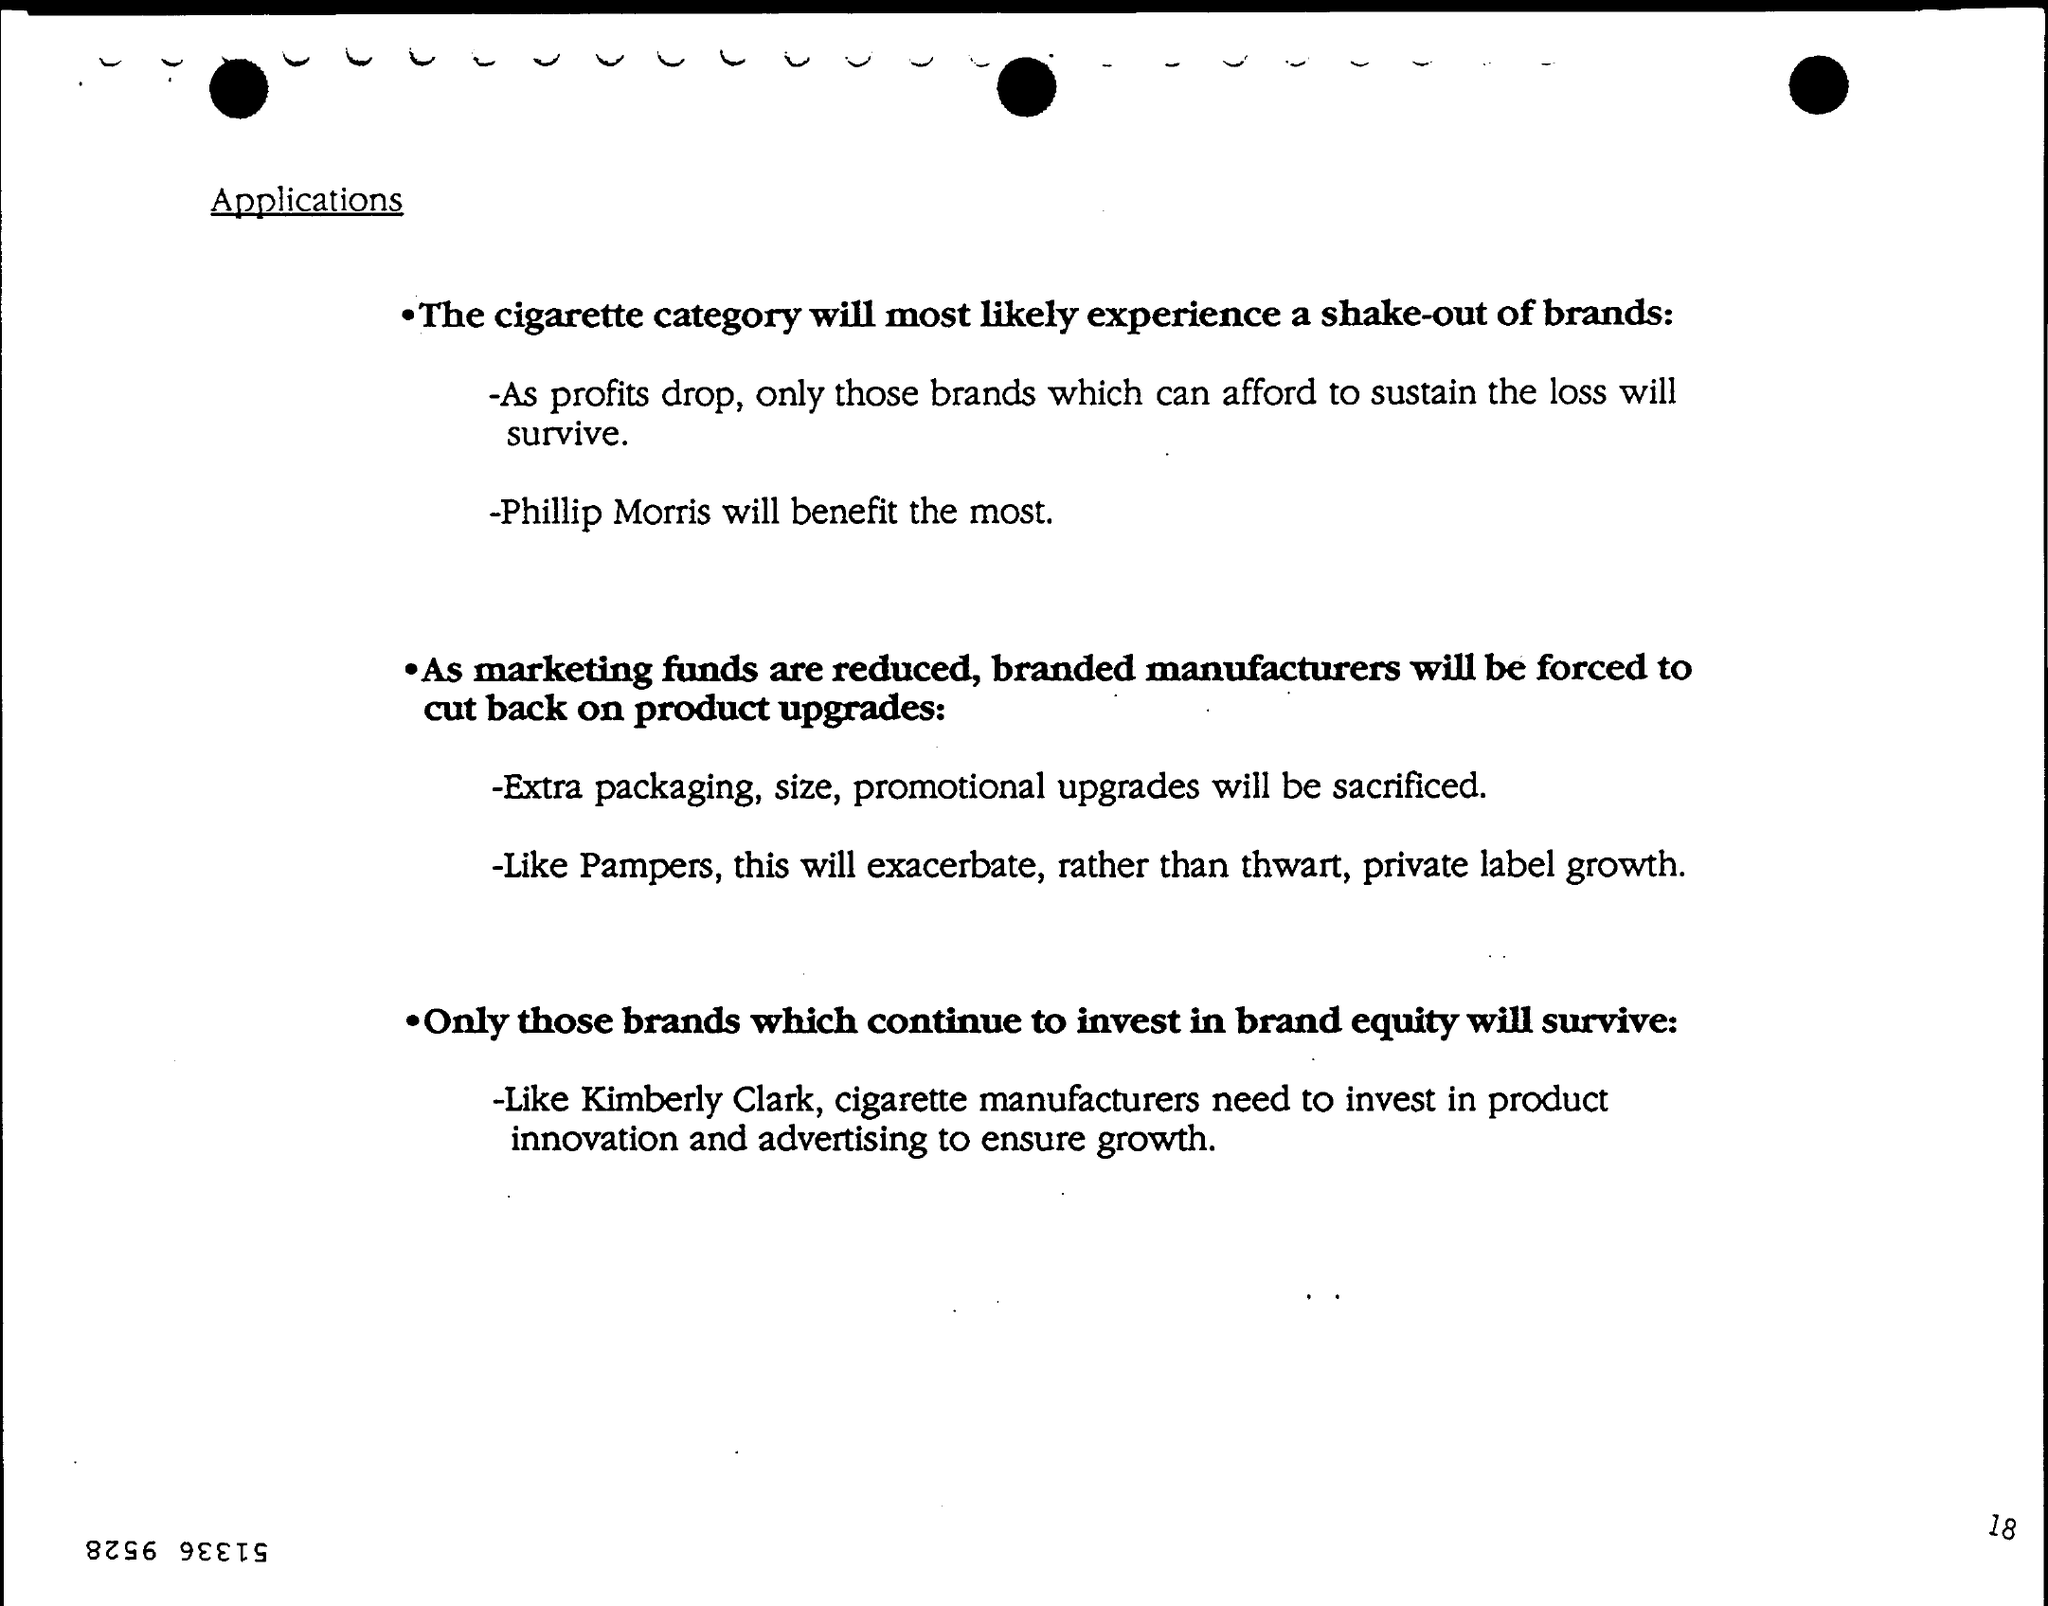Which cigarette brand will benefit the most?
Provide a short and direct response. Phillip morris. Which product upgrades will have to be sacrificed as marketing funds are reduced?
Keep it short and to the point. Extra packaging, size, promotional upgrades. Which brand invests in brand equity?
Your answer should be very brief. Kimberly clark. 